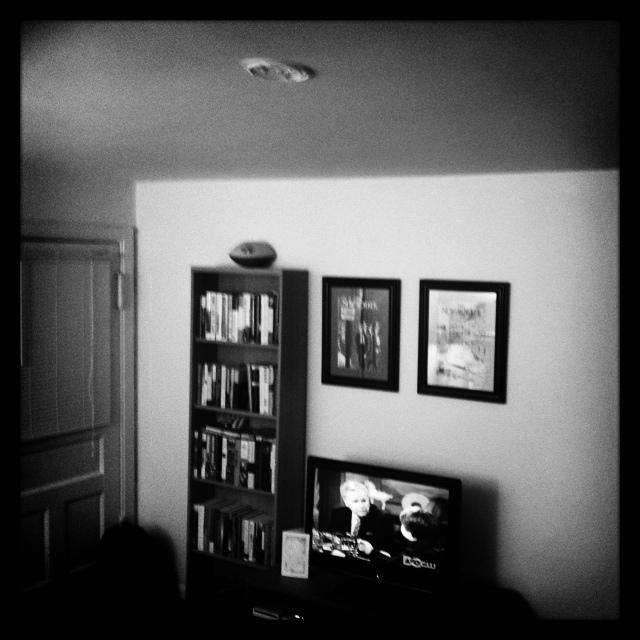Who is the woman the picture on wall?
Write a very short answer. There is unknown woman on television screen. Is the door open?
Quick response, please. No. Is the man on TV wearing a tie?
Write a very short answer. Yes. What objects are directly above the TV set?
Answer briefly. Pictures. 